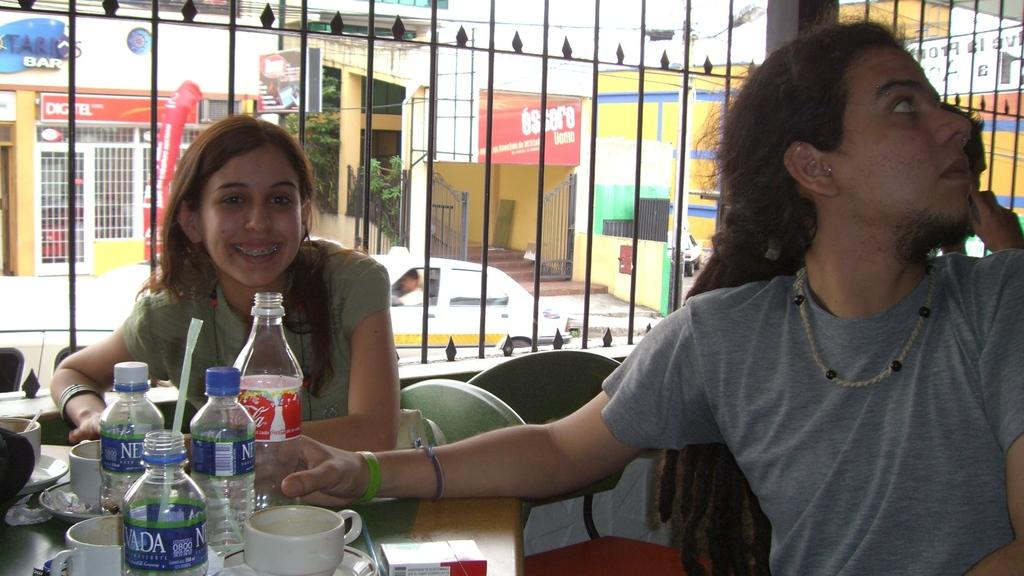How many people are in the image? There are two persons in the image. What is the woman doing in the image? The woman is sitting on a chair in front of a table. What can be seen on the table? There are different items on the table. What is visible through the windows in the image? Cars, buildings, and trees are visible through the windows. What type of board is being used by the woman to beam a mark onto the table? There is no board or beam present in the image, and the woman is not using any such tools. 